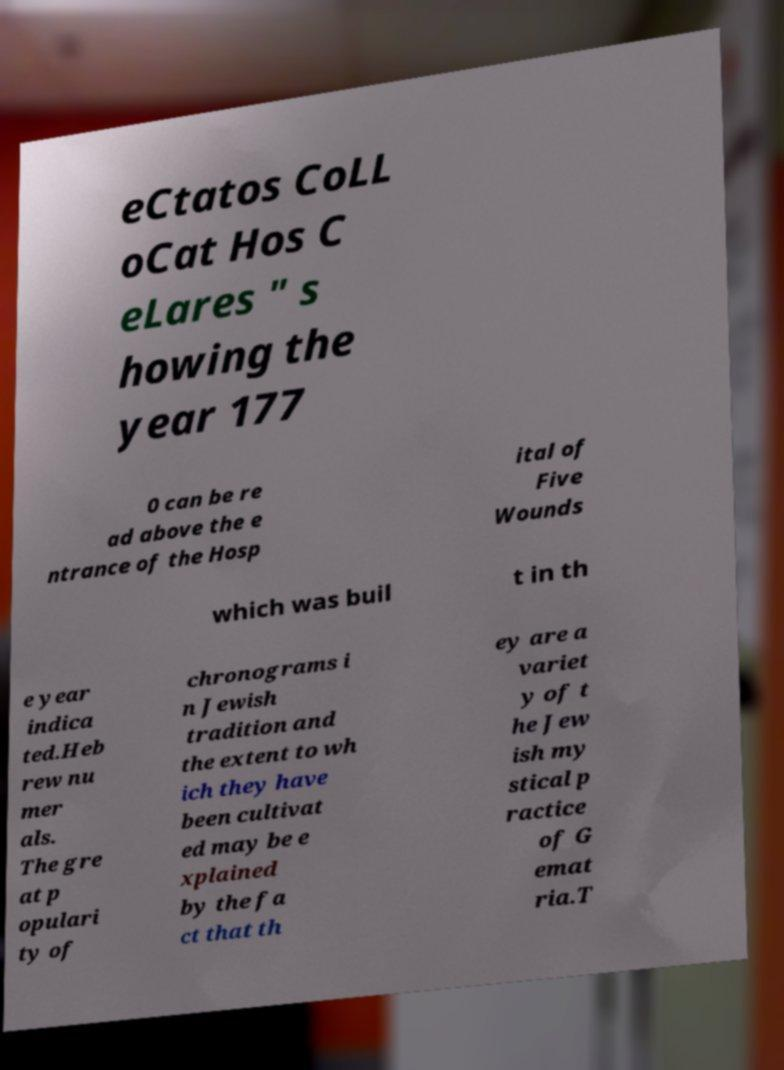What messages or text are displayed in this image? I need them in a readable, typed format. eCtatos CoLL oCat Hos C eLares " s howing the year 177 0 can be re ad above the e ntrance of the Hosp ital of Five Wounds which was buil t in th e year indica ted.Heb rew nu mer als. The gre at p opulari ty of chronograms i n Jewish tradition and the extent to wh ich they have been cultivat ed may be e xplained by the fa ct that th ey are a variet y of t he Jew ish my stical p ractice of G emat ria.T 